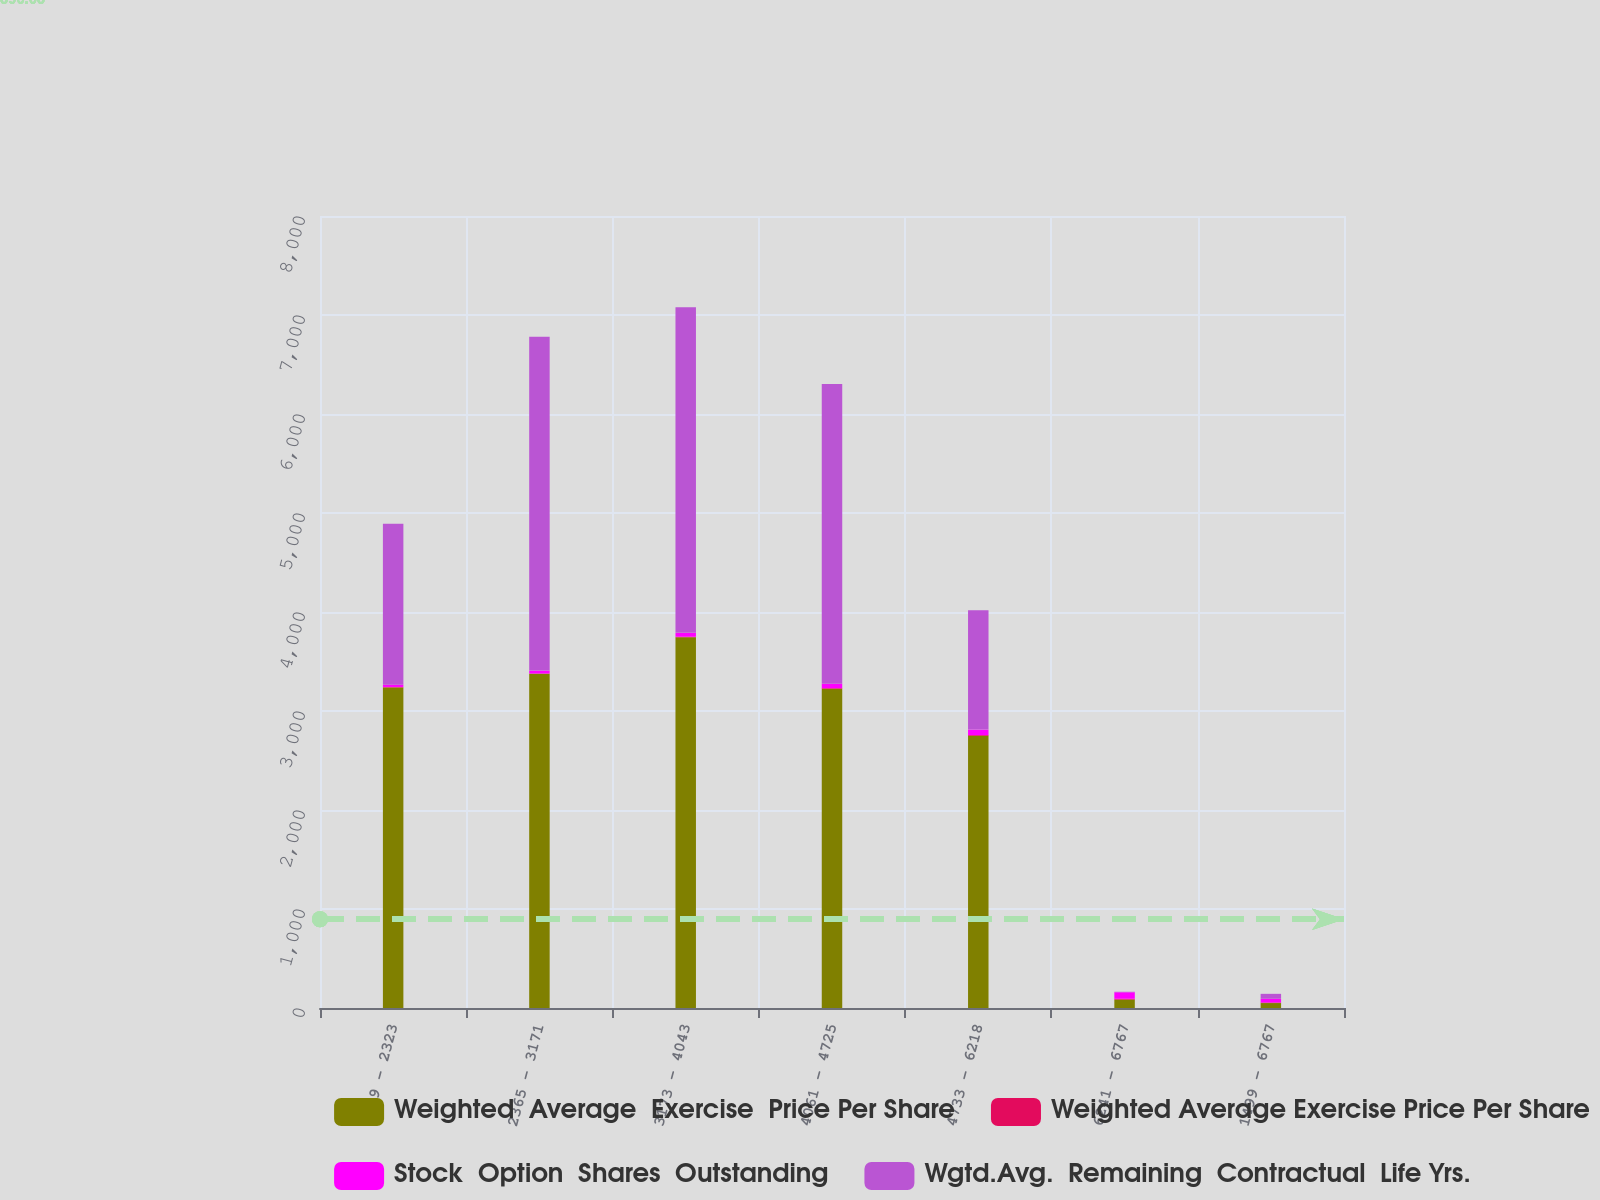Convert chart to OTSL. <chart><loc_0><loc_0><loc_500><loc_500><stacked_bar_chart><ecel><fcel>1499 - 2323<fcel>2365 - 3171<fcel>3173 - 4043<fcel>4061 - 4725<fcel>4733 - 6218<fcel>6241 - 6767<fcel>1499 - 6767<nl><fcel>Weighted  Average  Exercise  Price Per Share<fcel>3238<fcel>3376<fcel>3745<fcel>3224<fcel>2749<fcel>85<fcel>49.98<nl><fcel>Weighted Average Exercise Price Per Share<fcel>4.8<fcel>2.7<fcel>5.1<fcel>6.4<fcel>7.8<fcel>8.3<fcel>5.3<nl><fcel>Stock  Option  Shares  Outstanding<fcel>22.59<fcel>29.62<fcel>39.32<fcel>44.69<fcel>55.27<fcel>65.76<fcel>37.89<nl><fcel>Wgtd.Avg.  Remaining  Contractual  Life Yrs.<fcel>1626<fcel>3371<fcel>3289<fcel>3027<fcel>1205<fcel>5<fcel>49.98<nl></chart> 